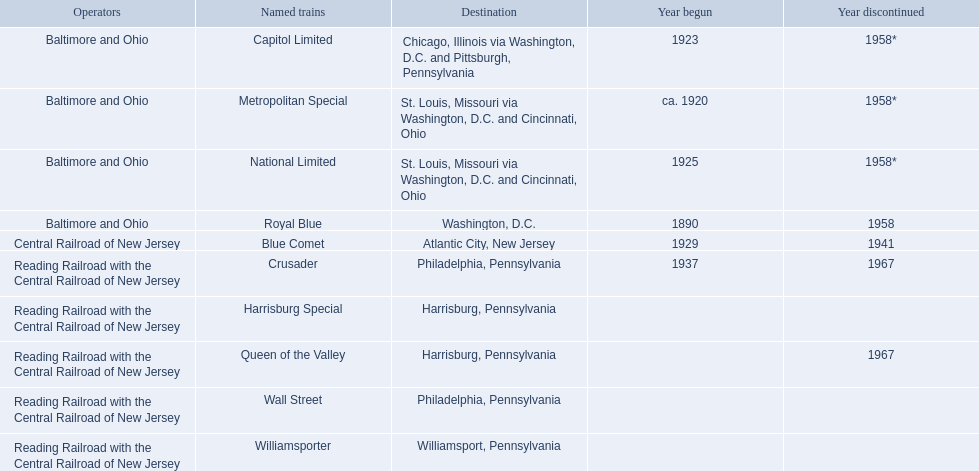Who are the operators for the reading railroad and the central railroad of new jersey? Reading Railroad with the Central Railroad of New Jersey, Reading Railroad with the Central Railroad of New Jersey, Reading Railroad with the Central Railroad of New Jersey, Reading Railroad with the Central Railroad of New Jersey, Reading Railroad with the Central Railroad of New Jersey. Which locations are in philadelphia, pennsylvania? Philadelphia, Pennsylvania, Philadelphia, Pennsylvania. What started in the year 1937? 1937. What is the train's name? Crusader. 